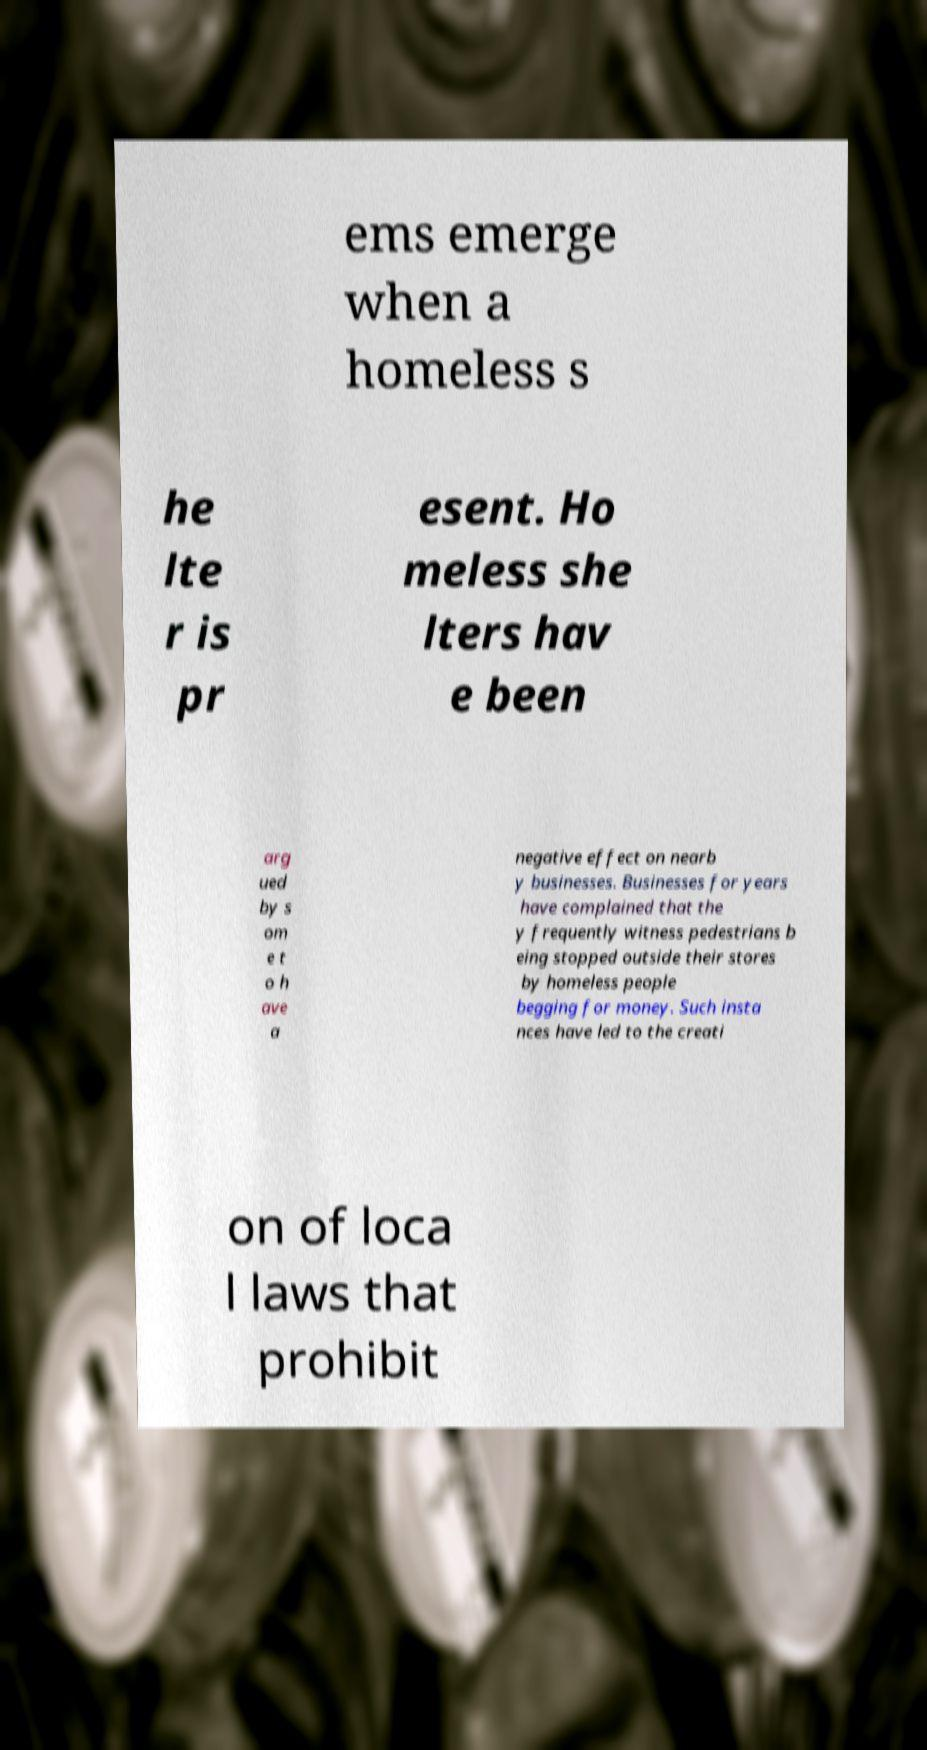Can you read and provide the text displayed in the image?This photo seems to have some interesting text. Can you extract and type it out for me? ems emerge when a homeless s he lte r is pr esent. Ho meless she lters hav e been arg ued by s om e t o h ave a negative effect on nearb y businesses. Businesses for years have complained that the y frequently witness pedestrians b eing stopped outside their stores by homeless people begging for money. Such insta nces have led to the creati on of loca l laws that prohibit 